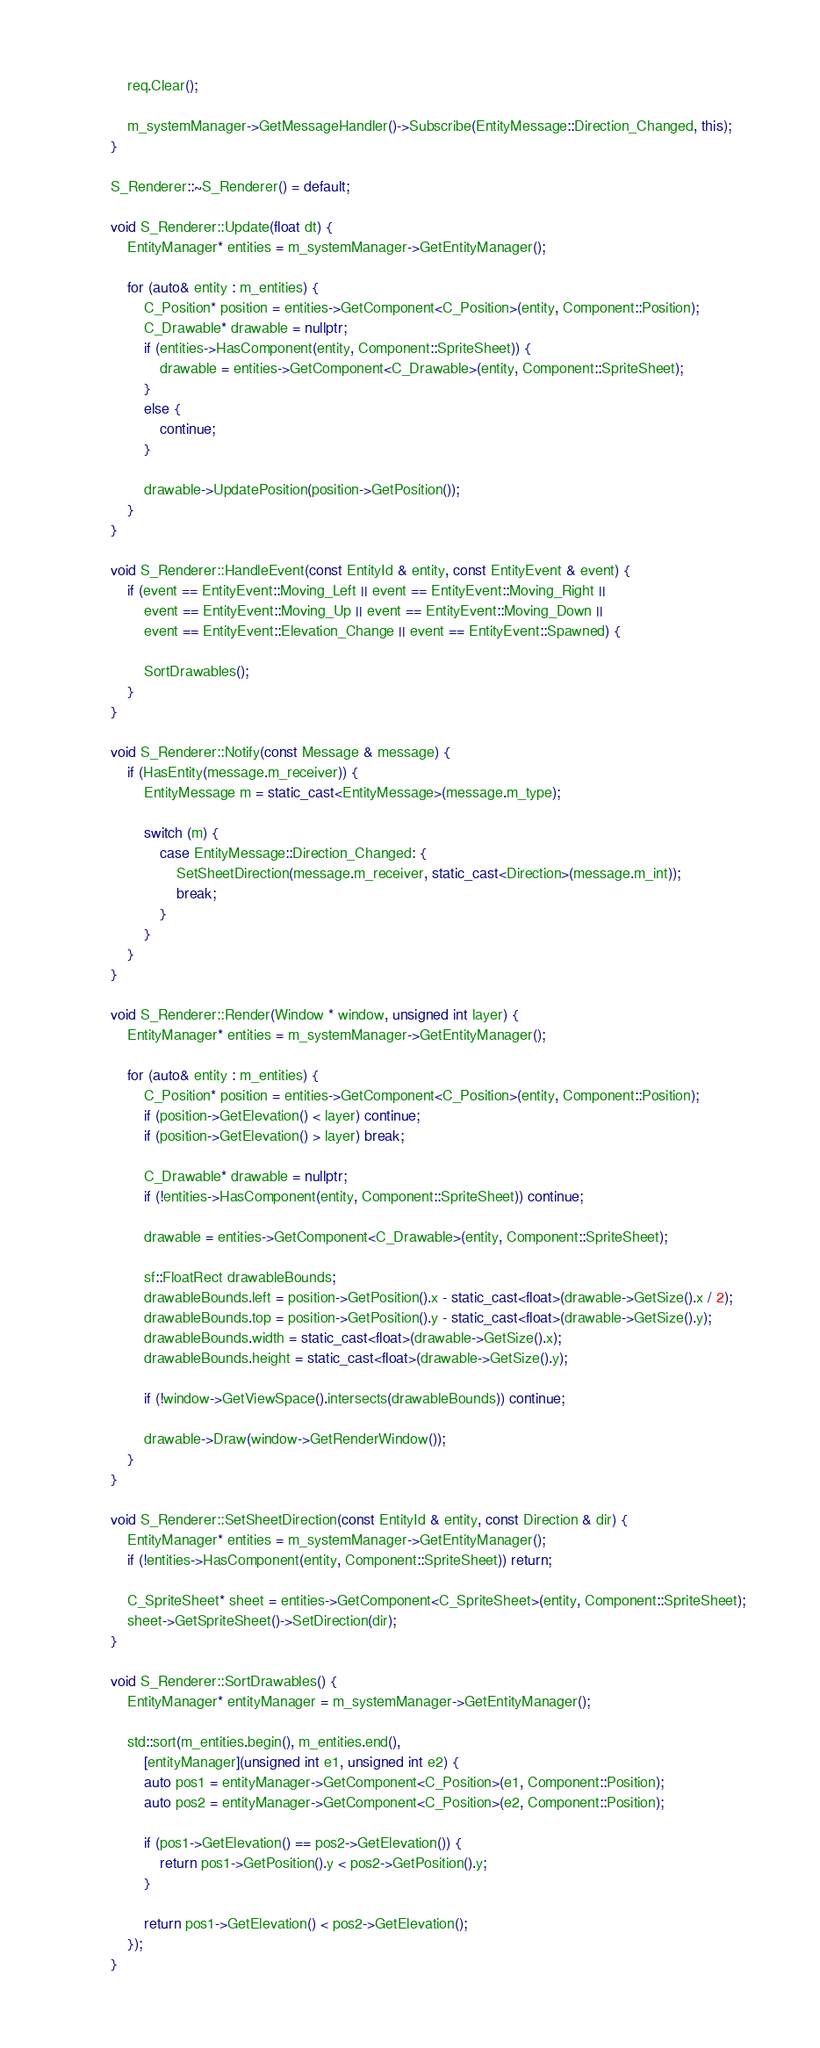<code> <loc_0><loc_0><loc_500><loc_500><_C++_>
	req.Clear();

	m_systemManager->GetMessageHandler()->Subscribe(EntityMessage::Direction_Changed, this);
}

S_Renderer::~S_Renderer() = default;

void S_Renderer::Update(float dt) {
	EntityManager* entities = m_systemManager->GetEntityManager();

	for (auto& entity : m_entities) {
		C_Position* position = entities->GetComponent<C_Position>(entity, Component::Position);
		C_Drawable* drawable = nullptr;
		if (entities->HasComponent(entity, Component::SpriteSheet)) {
			drawable = entities->GetComponent<C_Drawable>(entity, Component::SpriteSheet);
		}
		else {
			continue;
		}

		drawable->UpdatePosition(position->GetPosition());
	}
}

void S_Renderer::HandleEvent(const EntityId & entity, const EntityEvent & event) {
	if (event == EntityEvent::Moving_Left || event == EntityEvent::Moving_Right ||
		event == EntityEvent::Moving_Up || event == EntityEvent::Moving_Down ||
		event == EntityEvent::Elevation_Change || event == EntityEvent::Spawned) {

		SortDrawables();
	}
}

void S_Renderer::Notify(const Message & message) {
	if (HasEntity(message.m_receiver)) {
		EntityMessage m = static_cast<EntityMessage>(message.m_type);

		switch (m) {
			case EntityMessage::Direction_Changed: {
				SetSheetDirection(message.m_receiver, static_cast<Direction>(message.m_int));
				break;
			}
		}
	}
}

void S_Renderer::Render(Window * window, unsigned int layer) {
	EntityManager* entities = m_systemManager->GetEntityManager();

	for (auto& entity : m_entities) {
		C_Position* position = entities->GetComponent<C_Position>(entity, Component::Position);
		if (position->GetElevation() < layer) continue;
		if (position->GetElevation() > layer) break;

		C_Drawable* drawable = nullptr;
		if (!entities->HasComponent(entity, Component::SpriteSheet)) continue;

		drawable = entities->GetComponent<C_Drawable>(entity, Component::SpriteSheet);

		sf::FloatRect drawableBounds;
		drawableBounds.left = position->GetPosition().x - static_cast<float>(drawable->GetSize().x / 2);
		drawableBounds.top = position->GetPosition().y - static_cast<float>(drawable->GetSize().y);
		drawableBounds.width = static_cast<float>(drawable->GetSize().x);
		drawableBounds.height = static_cast<float>(drawable->GetSize().y);

		if (!window->GetViewSpace().intersects(drawableBounds)) continue;

		drawable->Draw(window->GetRenderWindow());
	}
}

void S_Renderer::SetSheetDirection(const EntityId & entity, const Direction & dir) {
	EntityManager* entities = m_systemManager->GetEntityManager();
	if (!entities->HasComponent(entity, Component::SpriteSheet)) return;

	C_SpriteSheet* sheet = entities->GetComponent<C_SpriteSheet>(entity, Component::SpriteSheet);
	sheet->GetSpriteSheet()->SetDirection(dir);
}

void S_Renderer::SortDrawables() {
	EntityManager* entityManager = m_systemManager->GetEntityManager();

	std::sort(m_entities.begin(), m_entities.end(),
		[entityManager](unsigned int e1, unsigned int e2) {
		auto pos1 = entityManager->GetComponent<C_Position>(e1, Component::Position);
		auto pos2 = entityManager->GetComponent<C_Position>(e2, Component::Position);

		if (pos1->GetElevation() == pos2->GetElevation()) {
			return pos1->GetPosition().y < pos2->GetPosition().y;
		}

		return pos1->GetElevation() < pos2->GetElevation();
	});
}</code> 